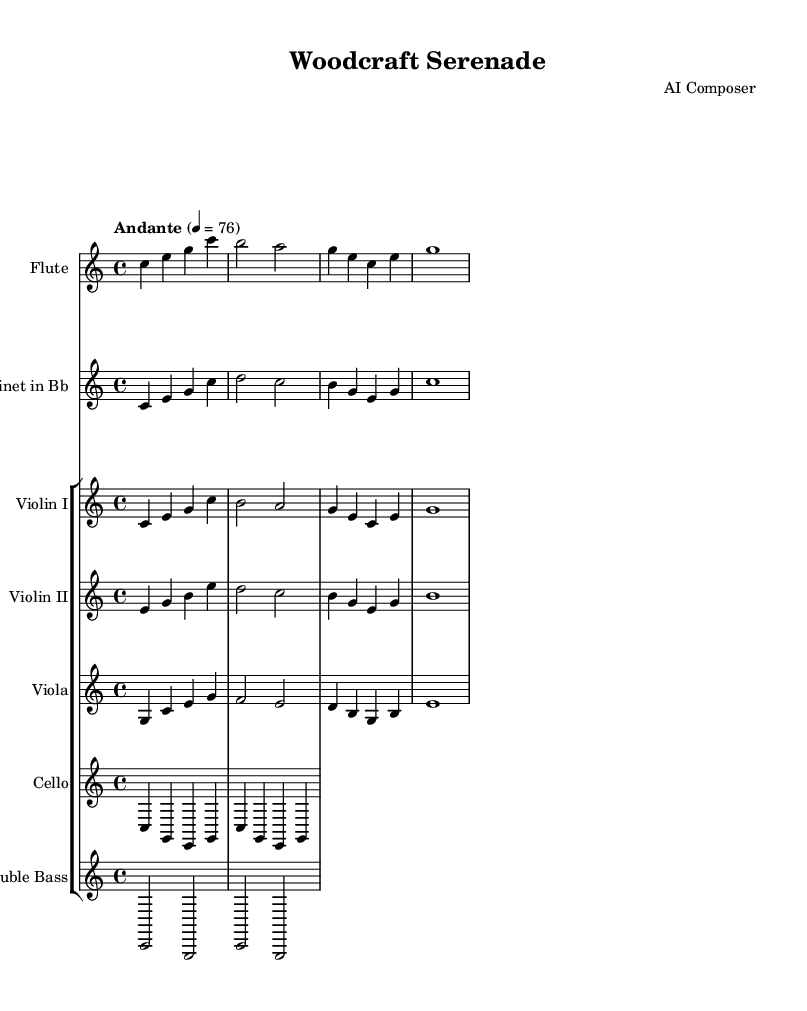What is the key signature of this music? The key signature is C major, which is indicated at the beginning of the score and has no sharps or flats.
Answer: C major What is the time signature of this piece? The time signature of the piece, shown at the beginning, is 4/4, which indicates four beats per measure with a quarter note getting one beat.
Answer: 4/4 What is the tempo marking for the symphony? The tempo marking is found near the beginning of the score and indicates that the piece should be played at an Andante speed, with a metronome mark of 76 beats per minute.
Answer: Andante How many instruments are featured in this symphony? The score lists a total of six different instruments: Flute, Clarinet, Violin I, Violin II, Viola, Cello, and Double Bass, which can be counted from the ensemble section of the score.
Answer: Six Which instrument has the first melodic line? The Flute is the first instrument to present the melodic line, as it appears at the beginning of the score and plays the first notes before the other instruments come in.
Answer: Flute In what kind of musical texture does this piece primarily exist? The piece is characterized by a homophonic texture, where a single melodic line is supported by accompaniment from the other instruments, creating a clear and elegant sound typical of minimalist symphonies.
Answer: Homophonic What is the significance of the repeated motifs in the symphony? The repeated motifs create a sense of simplicity and elegance, emphasizing the minimalist approach of the composition. This repetition allows the listener to appreciate the craftsmanship of the musical phrases, akin to well-crafted wooden objects.
Answer: Simplicity and elegance 